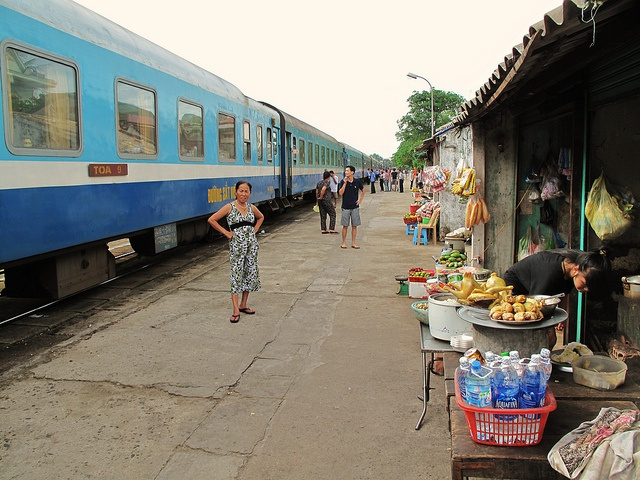Describe the objects in this image and their specific colors. I can see train in ivory, darkgray, black, teal, and darkblue tones, people in darkgray, black, gray, and maroon tones, people in darkgray, gray, black, and brown tones, bowl in darkgray, gray, and tan tones, and bottle in darkgray, gray, and blue tones in this image. 